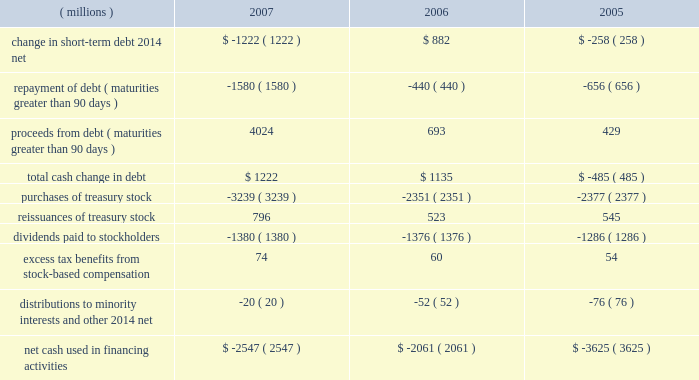Approximately $ 55 million , which is reported as 201cinvestments 201d in the consolidated balance sheet and as 201cpurchases of marketable securities and investments 201d in the consolidated statement of cash flows .
The recovery of approximately $ 25 million of this investment in 2007 reduced 201cinvestments 201d and is shown in cash flows within 201cproceeds from sale of marketable securities and investments . 201d this investment is discussed in more detail under the preceding section entitled industrial and transportation business .
Additional purchases of investments include additional survivor benefit insurance and equity investments .
Cash flows from financing activities : years ended december 31 .
Total debt at december 31 , 2007 , was $ 4.920 billion , up from $ 3.553 billion at year-end 2006 .
The net change in short-term debt is primarily due to commercial paper activity .
In 2007 , the repayment of debt for maturities greater than 90 days is primarily comprised of commercial paper repayments of approximately $ 1.15 billion and the november 2007 redemption of approximately $ 322 million in convertible notes .
In 2007 , proceeds from debt included long-term debt and commercial paper issuances totaling approximately $ 4 billion .
This was comprised of eurobond issuances in december 2007 and july 2007 totaling approximately $ 1.5 billion in u.s .
Dollars , a march 2007 long-term debt issuance of $ 750 million and a december 2007 fixed rate note issuance of $ 500 million , plus commercial paper issuances ( maturities greater than 90 days ) of approximately $ 1.25 billion .
Increases in long-term debt have been used , in part , to fund share repurchase activities .
The company accelerated purchases of treasury stock when compared to prior years , buying back $ 3.2 billion in shares in 2007 .
Total debt was 30% ( 30 % ) of total capital ( total capital is defined as debt plus equity ) , compared with 26% ( 26 % ) at year-end 2006 .
Debt securities , including 2007 debt issuances , the company 2019s shelf registration , dealer remarketable securities and convertible notes , are all discussed in more detail in note 10 .
The company has a "well-known seasoned issuer" shelf registration statement , effective february 24 , 2006 , to register an indeterminate amount of debt or equity securities for future sales .
On june 15 , 2007 , the company registered 150718 shares of the company's common stock under this shelf on behalf of and for the sole benefit of the selling stockholders in connection with the company's acquisition of assets of diamond productions , inc .
The company intends to use the proceeds from future securities sales off this shelf for general corporate purposes .
In connection with this shelf registration , in june 2007 the company established a medium-term notes program through which up to $ 3 billion of medium-term notes may be offered .
In december 2007 , 3m issued a five-year , $ 500 million , fixed rate note with a coupon rate of 4.65% ( 4.65 % ) under this medium-term notes program .
This program has a remaining capacity of $ 2.5 billion as of december 31 , 2007 .
The company 2019s $ 350 million of dealer remarketable securities ( classified as current portion of long-term debt ) were remarketed for one year in december 2007 .
At december 31 , 2007 , $ 350 million of dealer remarketable securities ( final maturity 2010 ) and $ 62 million of floating rate notes ( final maturity 2044 ) are classified as current portion of long- term debt as the result of put provisions associated with these debt instruments .
The company has convertible notes with a book value of $ 222 million at december 31 , 2007 .
The next put option date for these convertible notes is november 2012 .
In november 2007 , 364598 outstanding bonds were redeemed resulting in a payout from 3m of approximately $ 322 million .
Repurchases of common stock are made to support the company 2019s stock-based employee compensation plans and for other corporate purposes .
In february 2007 , 3m 2019s board of directors authorized a two-year share repurchase of up to $ 7.0 billion for the period from february 12 , 2007 to february 28 , 2009 .
As of december 31 , 2007 , approximately $ 4.1 billion remained available for repurchase .
Refer to the table titled 201cissuer purchases of equity securities 201d in part ii , item 5 , for more information. .
What was percentage change in the net cash used in financing activities from 2006 to 2007? 
Computations: ((2547 - 2061) / 2061)
Answer: 0.23581. 